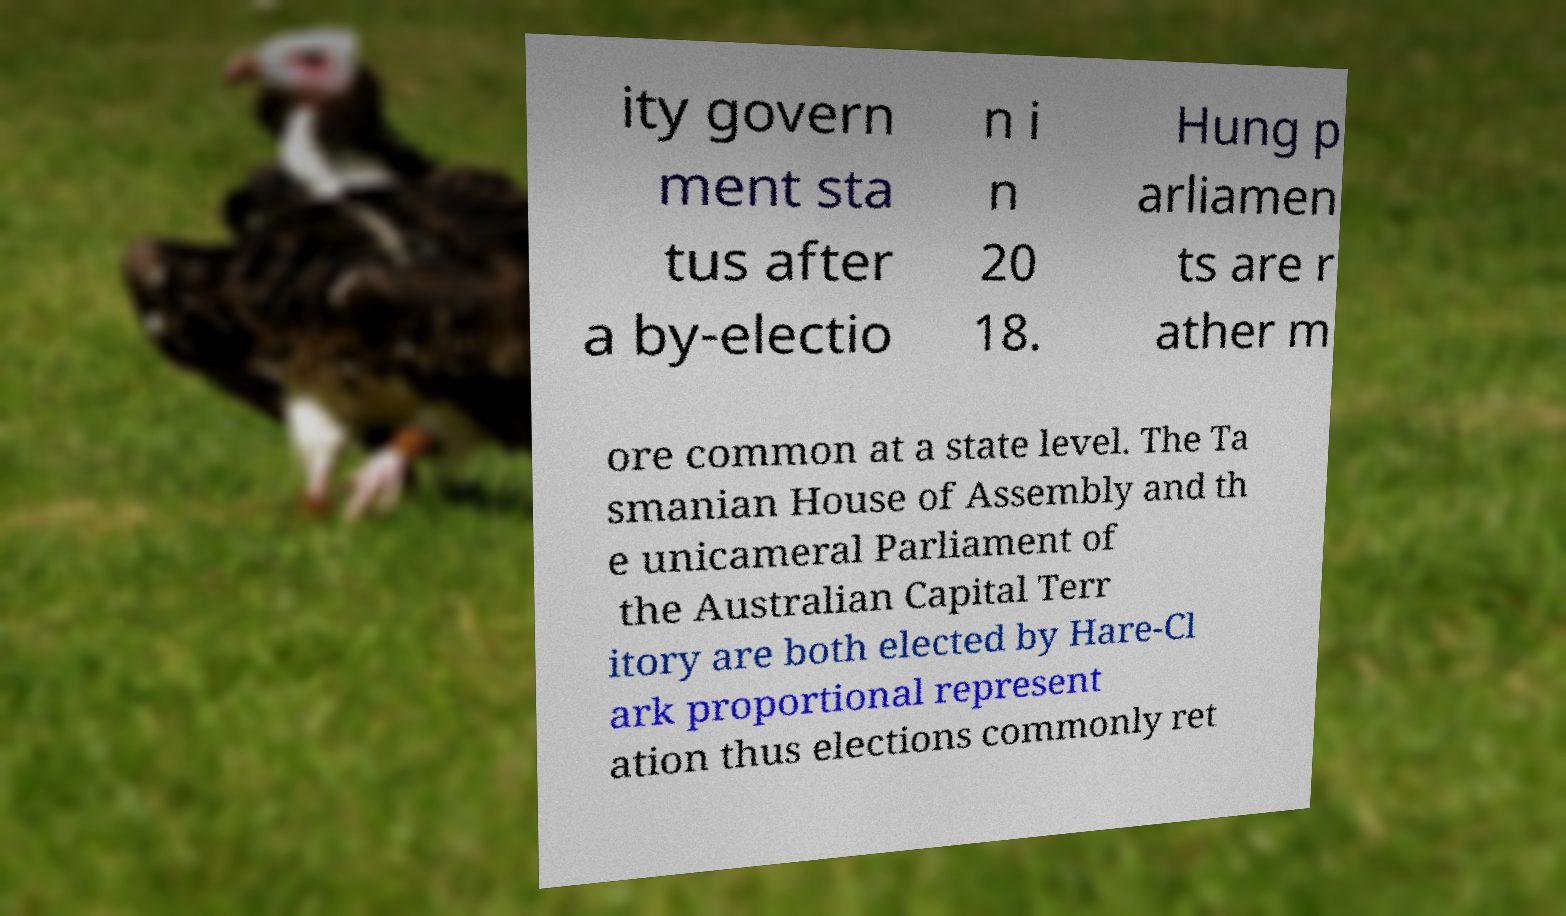What messages or text are displayed in this image? I need them in a readable, typed format. ity govern ment sta tus after a by-electio n i n 20 18. Hung p arliamen ts are r ather m ore common at a state level. The Ta smanian House of Assembly and th e unicameral Parliament of the Australian Capital Terr itory are both elected by Hare-Cl ark proportional represent ation thus elections commonly ret 